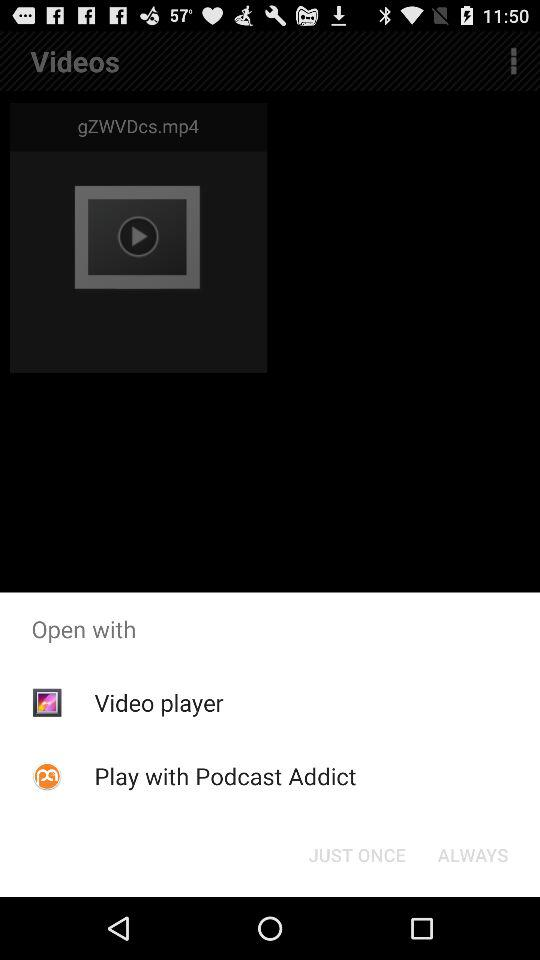Which application can we use to open with? You can use "Video player" or "Podcast Addict" to open with. 